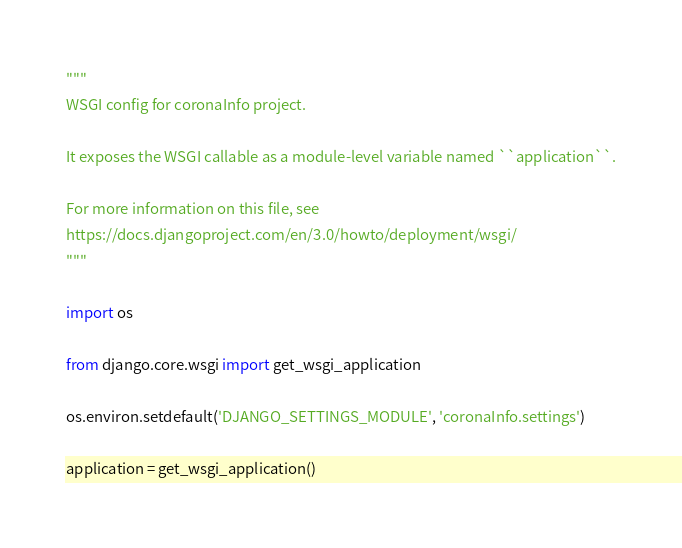<code> <loc_0><loc_0><loc_500><loc_500><_Python_>"""
WSGI config for coronaInfo project.

It exposes the WSGI callable as a module-level variable named ``application``.

For more information on this file, see
https://docs.djangoproject.com/en/3.0/howto/deployment/wsgi/
"""

import os

from django.core.wsgi import get_wsgi_application

os.environ.setdefault('DJANGO_SETTINGS_MODULE', 'coronaInfo.settings')

application = get_wsgi_application()
</code> 